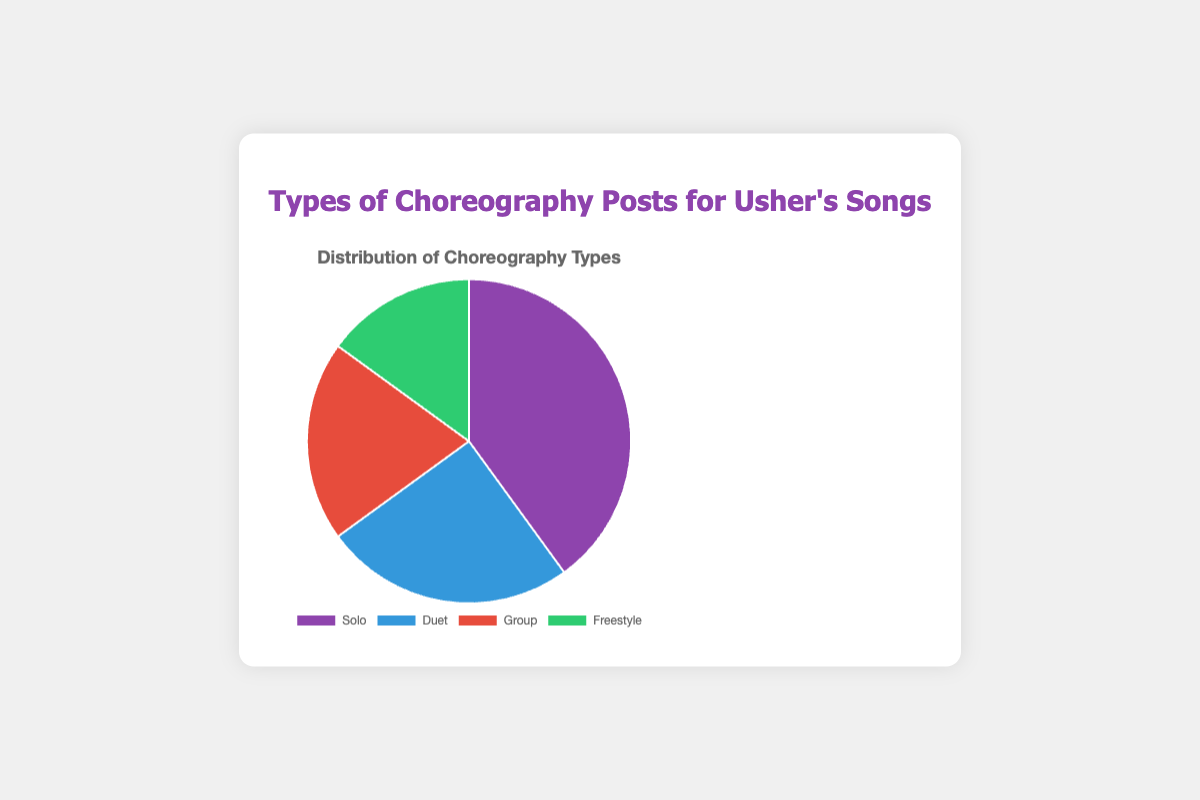What percentage of choreography posts are Solo? The Solo type is represented by one segment in the pie chart labeled as "Solo". To find the percentage, we look at the label which shows 40%.
Answer: 40% Which type of choreography post is the least common? The pie chart shows four types of posts, each with a percentage label. The "Freestyle" segment has the lowest percentage of 15%.
Answer: Freestyle How much more common are Solo posts compared to Group posts? The Solo posts have a percentage of 40%, and the Group posts have a percentage of 20%. The difference is 40% - 20% = 20%.
Answer: 20% What is the sum of the percentages of Duet and Group posts? The Duet posts have a percentage of 25%, and the Group posts have a percentage of 20%. Adding them together, we get 25% + 20% = 45%.
Answer: 45% If you combine the percentages of Freestyle and Duet posts, is the total percentage greater or less than Solo posts? The Freestyle posts are 15%, and the Duet posts are 25%. Adding them gives 15% + 25% = 40%. This is equal to the percentage of Solo posts.
Answer: Equal How does the percentage of Freestyle posts compare to the total percentage of Duet and Group posts? First, find the total percentage for Duet and Group posts by adding 25% and 20%, which equals 45%. The percentage for Freestyle posts is 15%. Therefore, 15% is less than 45%.
Answer: Less What is the average percentage of Solo and Duet posts? The Solo posts have a percentage of 40%, and Duet posts have a percentage of 25%. The average is (40% + 25%) / 2 = 32.5%.
Answer: 32.5% Which section of the pie chart is represented by the color green? According to the legend and color distribution on the pie chart, the "Freestyle" segment is in green.
Answer: Freestyle Is the sum of the percentages of Group and Freestyle posts greater than 30%? The Group posts have a percentage of 20%, and Freestyle posts have a percentage of 15%. Adding them gives 20% + 15% = 35%, which is greater than 30%.
Answer: Yes If you were to visualize half of the total Duet posts on another chart, what percentage would that be? The Duet posts account for 25%. Half of this value is calculated by dividing 25% by 2, which equals 12.5%.
Answer: 12.5% 